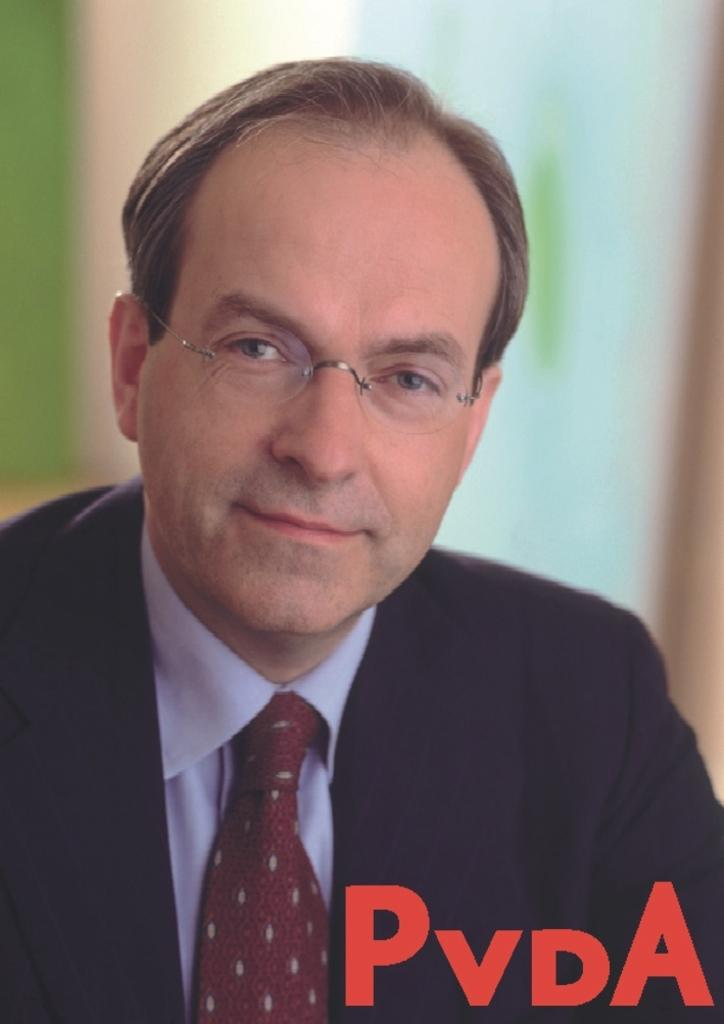What is present in the image? There is a person in the image. Can you describe the person's attire? The person is wearing a shirt, a tie, and a black colored blazer. What can be said about the background of the image? The background of the image is blurry. What type of pies are being served at the person's birthday celebration in the image? There is no indication of a birthday celebration or pies in the image; it only features a person wearing a shirt, tie, and black blazer with a blurry background. 